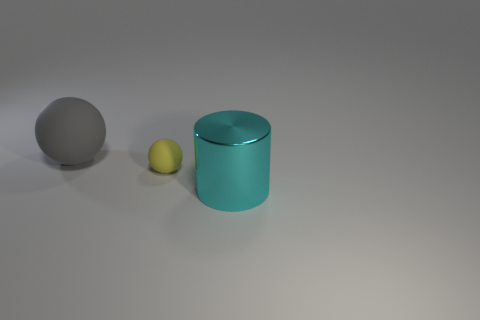Add 3 purple metallic spheres. How many objects exist? 6 Subtract all balls. How many objects are left? 1 Subtract 0 green cylinders. How many objects are left? 3 Subtract all big gray things. Subtract all small shiny blocks. How many objects are left? 2 Add 2 large cyan metal things. How many large cyan metal things are left? 3 Add 3 big gray matte cubes. How many big gray matte cubes exist? 3 